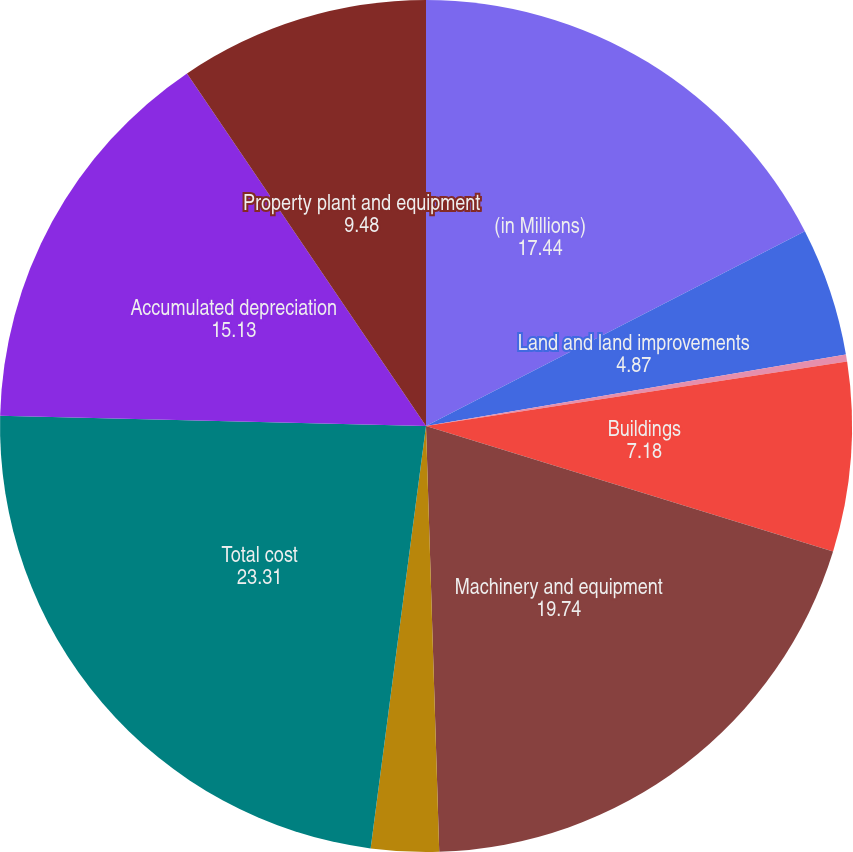<chart> <loc_0><loc_0><loc_500><loc_500><pie_chart><fcel>(in Millions)<fcel>Land and land improvements<fcel>Mineral rights<fcel>Buildings<fcel>Machinery and equipment<fcel>Construction in progress<fcel>Total cost<fcel>Accumulated depreciation<fcel>Property plant and equipment<nl><fcel>17.44%<fcel>4.87%<fcel>0.27%<fcel>7.18%<fcel>19.74%<fcel>2.57%<fcel>23.31%<fcel>15.13%<fcel>9.48%<nl></chart> 